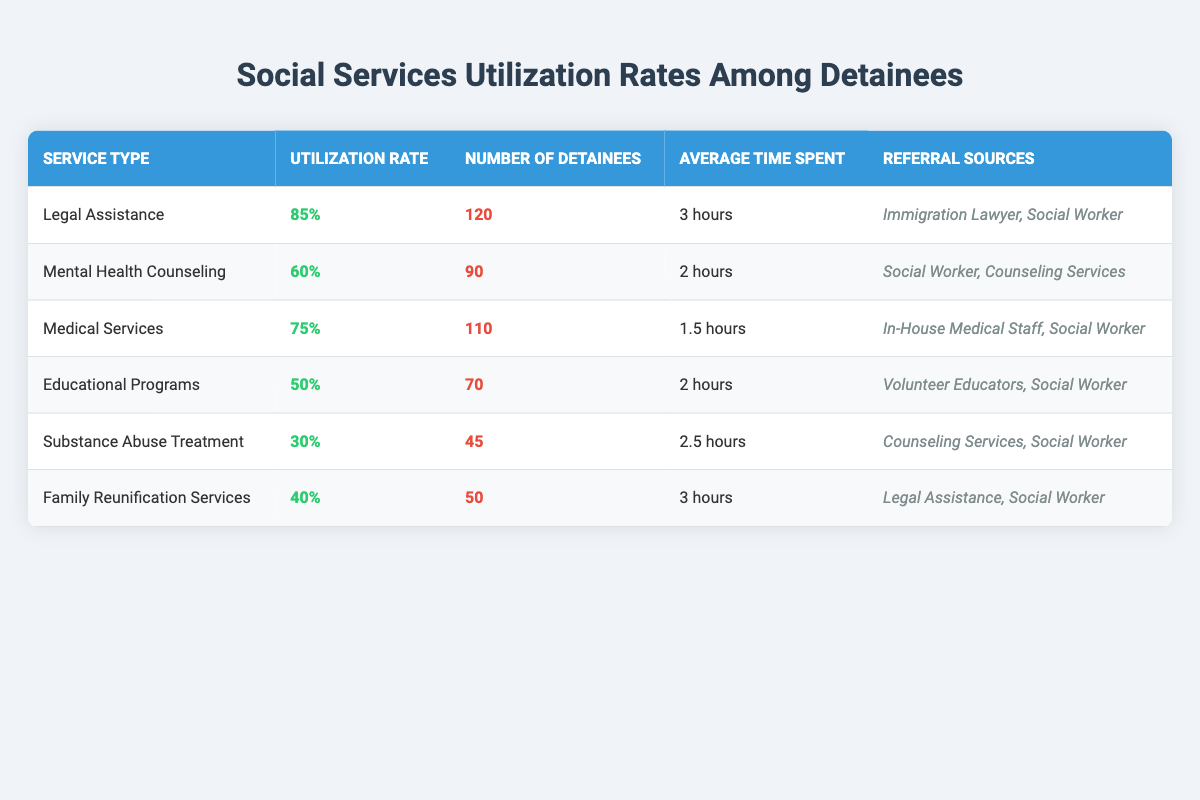What is the utilization rate for Legal Assistance? The table lists the utilization rate for each service type, and for Legal Assistance, it is explicitly stated as 85%.
Answer: 85% How many detainees utilized Mental Health Counseling services? The table shows that the number of detainees who utilized Mental Health Counseling services is 90.
Answer: 90 What is the average time spent on Substance Abuse Treatment? The table provides an entry for Substance Abuse Treatment, indicating that the average time spent is 2.5 hours.
Answer: 2.5 hours Which service has the highest number of detainees? By comparing the number of detainees across all services in the table, Legal Assistance has 120 detainees, which is the highest among all services.
Answer: Legal Assistance What is the difference in utilization rates between Medical Services and Educational Programs? The utilization rate for Medical Services is 75% and for Educational Programs is 50%. The difference is 75% - 50% = 25%.
Answer: 25% Can you confirm if the referral source for Family Reunification Services includes a Social Worker? The table shows that Social Worker is listed as one of the referral sources for Family Reunification Services.
Answer: Yes What is the total number of detainees who utilized Legal Assistance and Medical Services combined? Legal Assistance has 120 detainees and Medical Services has 110. Adding these together gives 120 + 110 = 230.
Answer: 230 What percentage of detainees utilized Substance Abuse Treatment compared to those who utilized Medical Services? Substance Abuse Treatment had 45 detainees (30% utilization) while Medical Services had 110 detainees (75% utilization). Comparing the two, 45 / 110 = 0.409, which is approximately 40.9%.
Answer: 40.9% Are there more detainees using Educational Programs than those using Family Reunification Services? Educational Programs had 70 detainees and Family Reunification Services had 50. Since 70 > 50, there are more detainees using Educational Programs.
Answer: Yes Calculate the average utilization rate for the services listed in the table. To find the average, sum the utilization rates: 85% + 60% + 75% + 50% + 30% + 40% = 340%. Then divide by the number of services (6). Thus, 340% / 6 = 56.67%.
Answer: 56.67% 